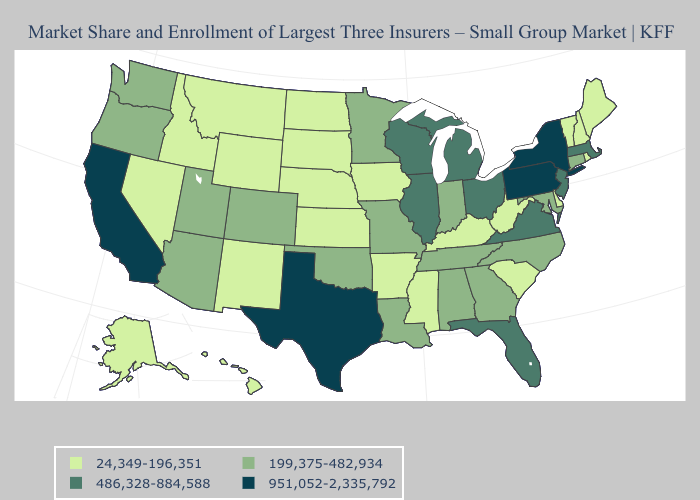What is the lowest value in states that border West Virginia?
Short answer required. 24,349-196,351. Which states have the lowest value in the Northeast?
Keep it brief. Maine, New Hampshire, Rhode Island, Vermont. Name the states that have a value in the range 24,349-196,351?
Be succinct. Alaska, Arkansas, Delaware, Hawaii, Idaho, Iowa, Kansas, Kentucky, Maine, Mississippi, Montana, Nebraska, Nevada, New Hampshire, New Mexico, North Dakota, Rhode Island, South Carolina, South Dakota, Vermont, West Virginia, Wyoming. Among the states that border Virginia , does West Virginia have the lowest value?
Be succinct. Yes. Does Florida have the lowest value in the South?
Write a very short answer. No. What is the highest value in the USA?
Concise answer only. 951,052-2,335,792. Does the first symbol in the legend represent the smallest category?
Short answer required. Yes. Name the states that have a value in the range 199,375-482,934?
Concise answer only. Alabama, Arizona, Colorado, Connecticut, Georgia, Indiana, Louisiana, Maryland, Minnesota, Missouri, North Carolina, Oklahoma, Oregon, Tennessee, Utah, Washington. Is the legend a continuous bar?
Short answer required. No. Does Illinois have the same value as Vermont?
Concise answer only. No. Which states have the highest value in the USA?
Short answer required. California, New York, Pennsylvania, Texas. Does Nebraska have the same value as Pennsylvania?
Short answer required. No. Name the states that have a value in the range 199,375-482,934?
Answer briefly. Alabama, Arizona, Colorado, Connecticut, Georgia, Indiana, Louisiana, Maryland, Minnesota, Missouri, North Carolina, Oklahoma, Oregon, Tennessee, Utah, Washington. What is the value of Ohio?
Short answer required. 486,328-884,588. Does Idaho have the highest value in the West?
Short answer required. No. 